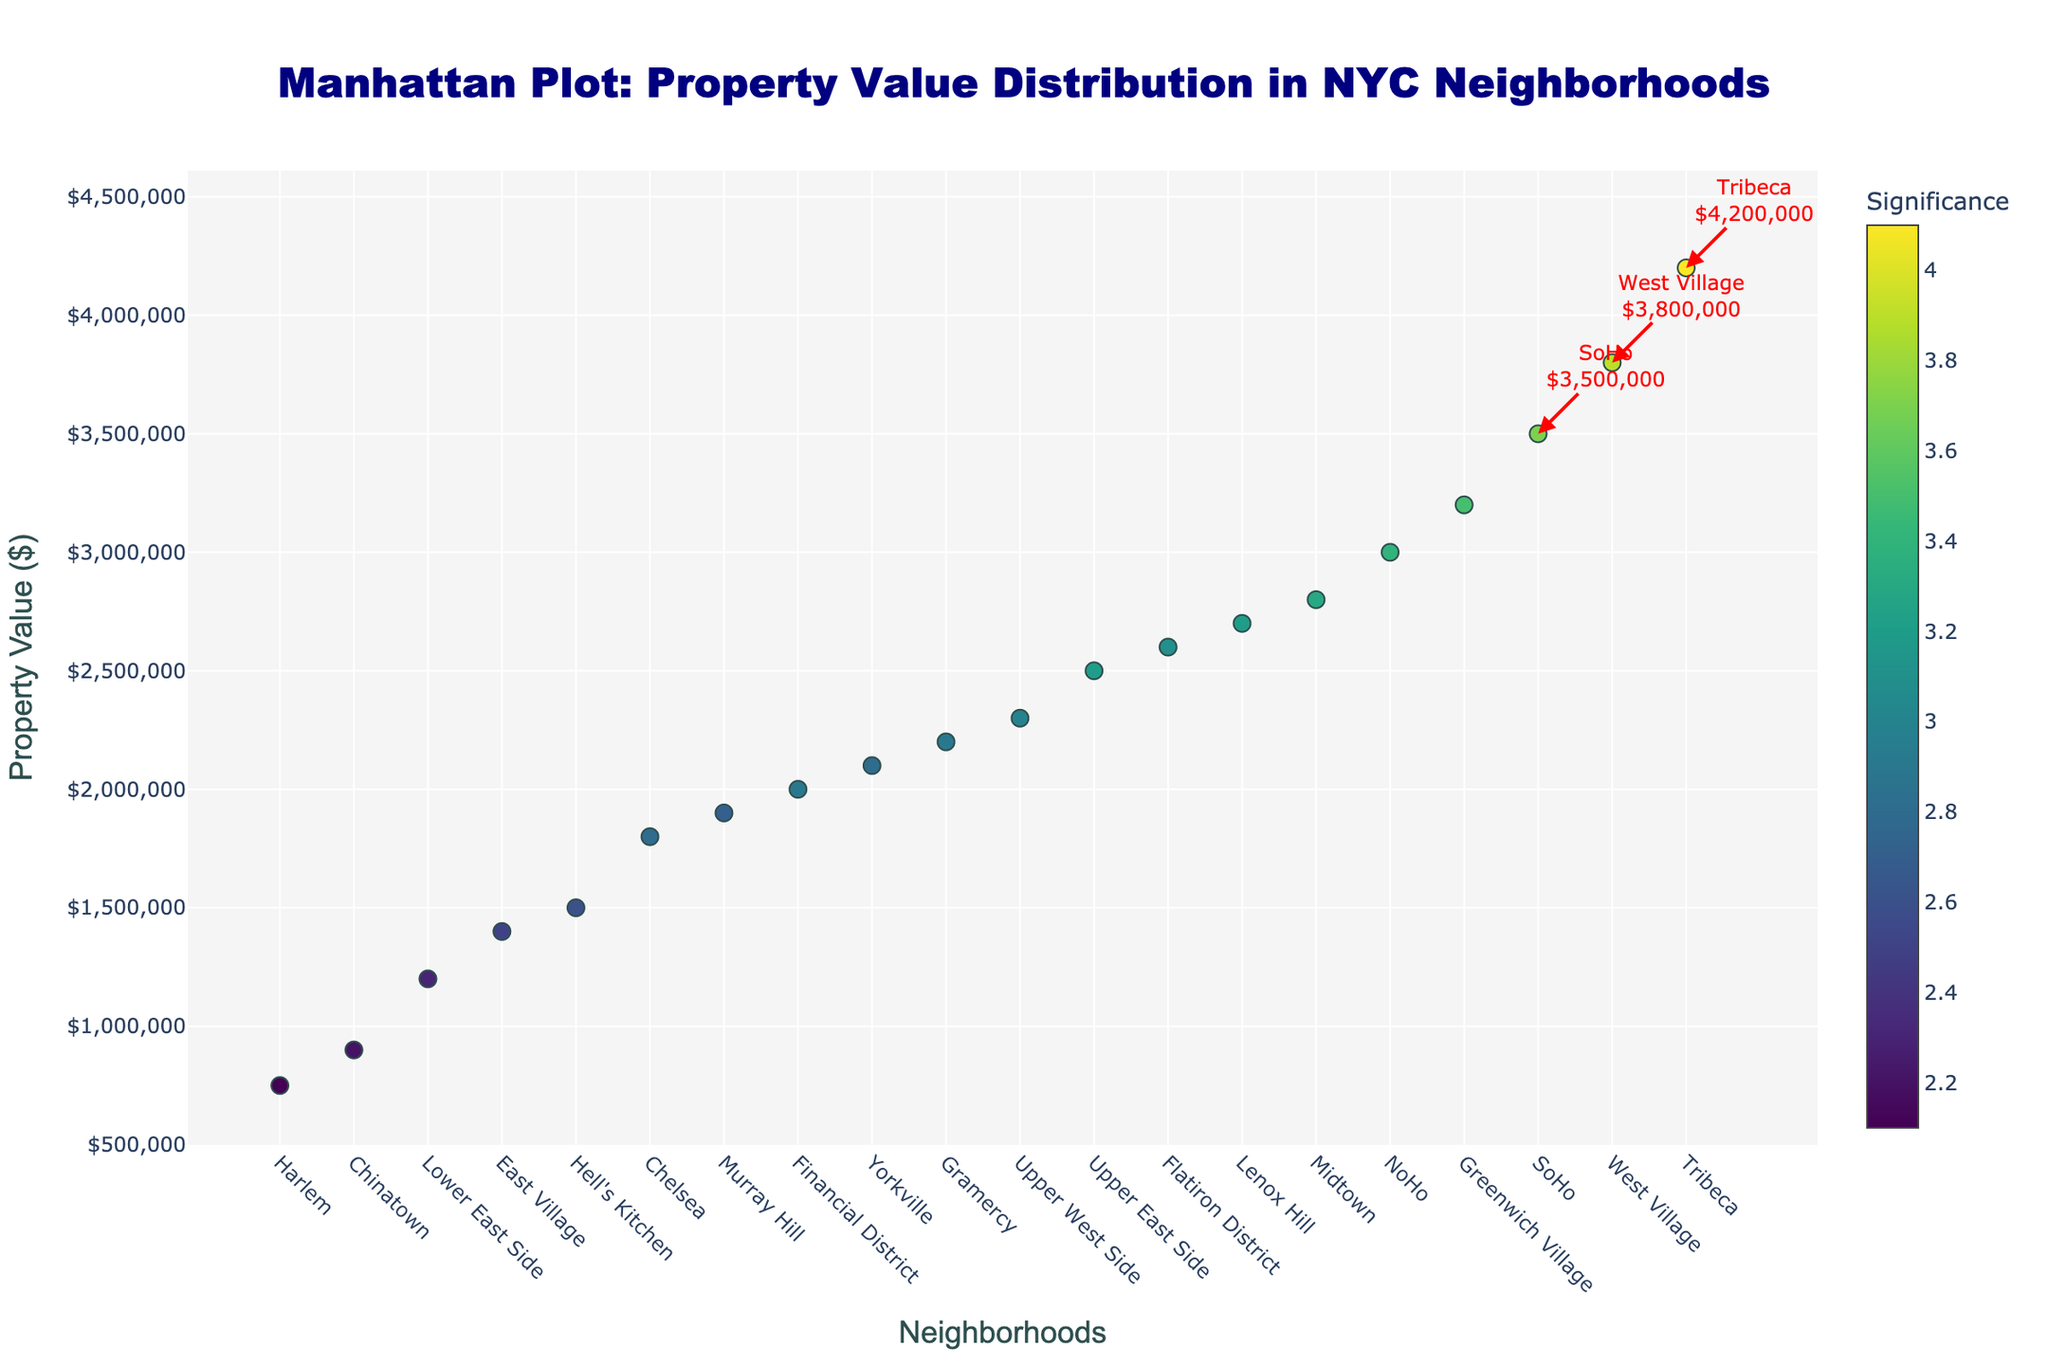Where is the highest property value located in Manhattan based on the plot? The plot shows various neighborhoods along the x-axis and their corresponding property values along the y-axis. By identifying the highest point on the y-axis, we can see that Tribeca has the highest property value among the neighborhoods.
Answer: Tribeca What is the significance level of properties in SoHo? By locating SoHo on the x-axis and looking at the color scale or the marker, we can see the significance level indicated by the color of the marker. SoHo's marker shows the significance level is 3.7.
Answer: 3.7 Which neighborhood demonstrates the lowest property value, and what is it? The plot's y-axis indicates property values. By identifying the lowest point on the y-axis, we find that Harlem has the lowest property value. The exact value can be read directly from the figure.
Answer: Harlem, $750,000 What trend can be observed in the distribution of property values among the neighborhoods? Observing the scatter plot, property values increase from Harlem to Tribeca, indicating a general upward trend in property values across neighborhoods. Closer inspection of dots' variation and color coding also reveals significance levels across different property values.
Answer: Property values increase from Harlem to Tribeca, indicating an upward trend How much higher is Tribeca's property value compared to Harlem's? By checking their respective property values on the y-axis, we have $4,200,000 for Tribeca and $750,000 for Harlem. Subtracting these values gives the difference: $4,200,000 - $750,000 = $3,450,000.
Answer: $3,450,000 What neighborhoods fall into the top three property values? The three highest markers on the y-axis should be identified. The top three neighborhoods with the highest property values are Tribeca, West Village, and SoHo.
Answer: Tribeca, West Village, SoHo Which neighborhoods have property values above $3,000,000? Checking the plot for neighborhoods with markers above the $3,000,000 line on the y-axis, we identify neighborhoods with property values surpassing this amount.
Answer: Tribeca, West Village, SoHo, Greenwich Village, and NoHo What is the significance of the marker colors, and how does it relate to property values? The plot uses colors to represent significance levels. By referring to the color scale bar, we can determine that darker hues indicate higher significance levels. This helps in understanding the significance of property values more visually.
Answer: The colors represent significance levels, with darker hues indicating higher significance What can be inferred about the distribution of property values across the plot? The scatter plot shows a wide range of values along the y-axis, concentrated with higher values from the mid-point towards the end, suggesting more high-value properties are found in specific neighborhoods.
Answer: High-value properties are concentrated in specific neighborhoods 